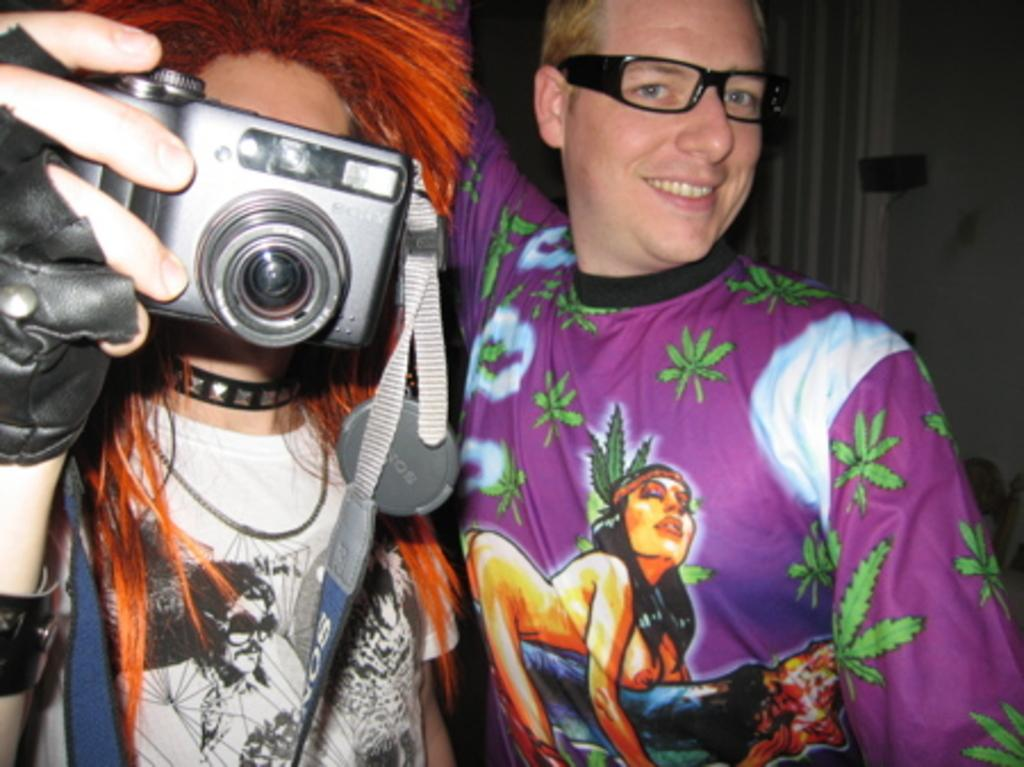How many people are present in the image? There are two people in the image. What is one person doing in the image? One person is holding a camera. What can be seen in the background of the image? There is a wall and other objects in the background of the image. What type of meeting is taking place in the image? There is no meeting present in the image; it features two people and a background with a wall and objects. 